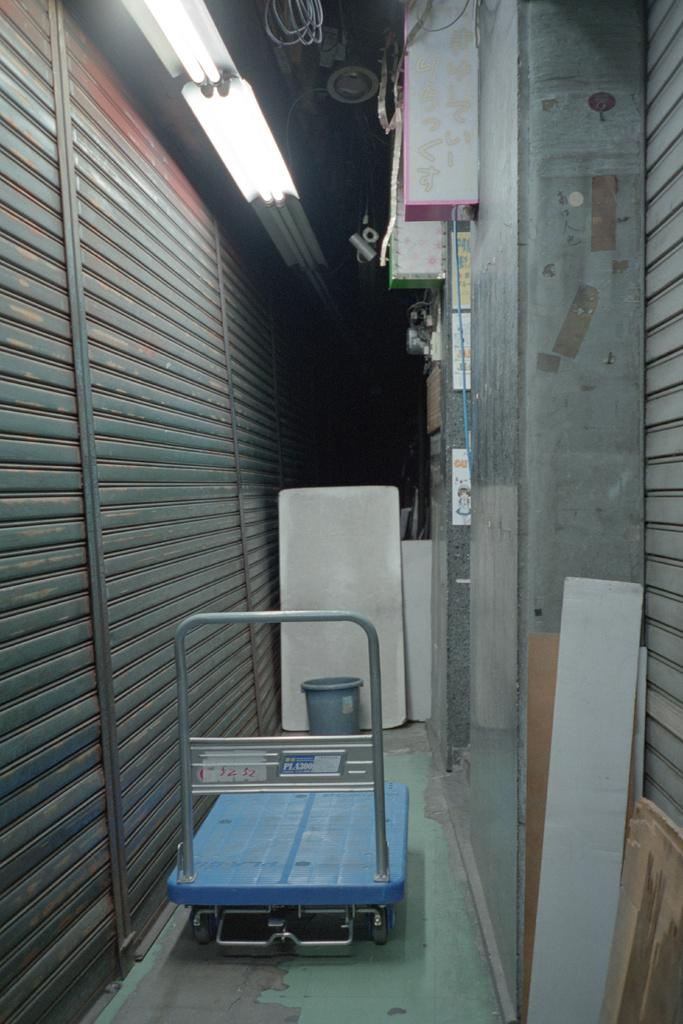What type of object is present in the image for transporting luggage? There is a luggage trolley in the image. What is the small container used for in the image? There is a small dustbin in the image. What type of material can be seen in the image for constructing a surface or structure? There are wooden planks in the image. What can be seen providing illumination in the image? There are lights visible in the image. What type of barrier is present on both sides of the image? Metal shutters are present on both sides of the image. What type of leather is used to create the art piece in the image? There is no leather or art piece present in the image. What is the base made of for the structure in the image? There is no structure or base mentioned in the provided facts, so we cannot determine the material. 